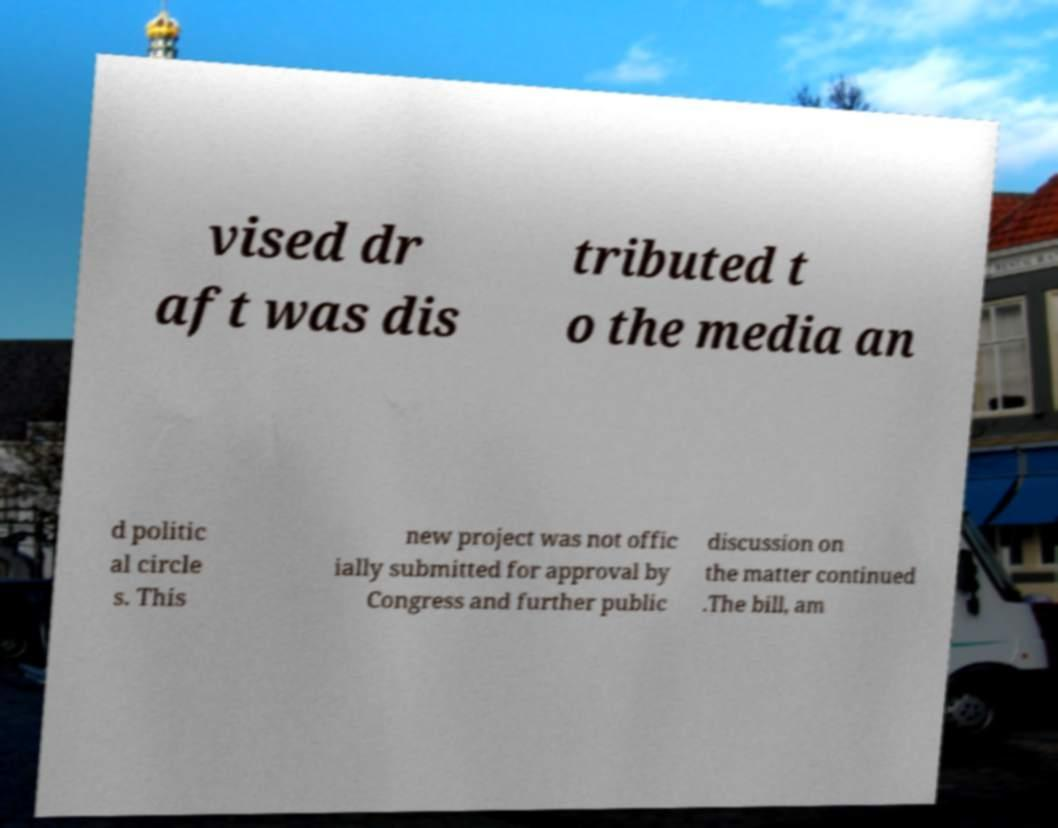Please read and relay the text visible in this image. What does it say? vised dr aft was dis tributed t o the media an d politic al circle s. This new project was not offic ially submitted for approval by Congress and further public discussion on the matter continued .The bill, am 